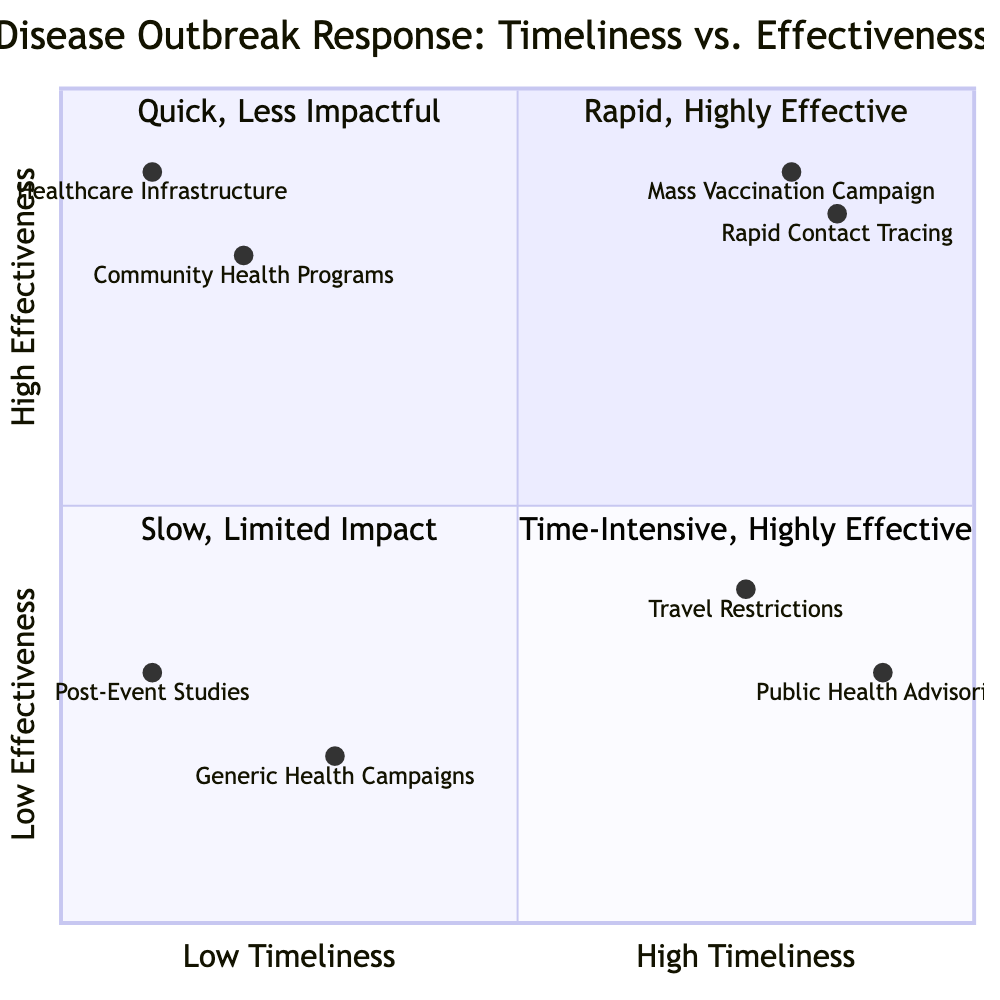What intervention is positioned in the high timeliness and high effectiveness quadrant? The diagram indicates that the interventions placed in the high timeliness and high effectiveness quadrant are the Mass Vaccination Campaign and Rapid Contact Tracing and Isolation. These interventions are effective in quickly addressing disease outbreaks.
Answer: Mass Vaccination Campaign, Rapid Contact Tracing and Isolation How many interventions are in the low timeliness and high effectiveness quadrant? By examining the diagram, it shows there are two interventions in the low timeliness and high effectiveness quadrant: Community Health Outreach Programs and Infrastructure Improvements in Healthcare Facilities. Thus, the count is two.
Answer: 2 Which intervention has the highest effectiveness among those classified as low timeliness? Looking at the diagram, the intervention classified as low timeliness but high effectiveness is Infrastructure Improvements in Healthcare Facilities, which is ranked higher compared to the others in that category.
Answer: Infrastructure Improvements in Healthcare Facilities What is the effectiveness score of Public Health Advisories? The diagram states that Public Health Advisories have an effectiveness score of 0.3. This score reflects its limited impact despite being timely advice for the public.
Answer: 0.3 Which intervention has the lowest timeliness score? A review of the diagram reveals that Post-Event Epidemiological Studies have the lowest timeliness score at 0.1, indicating a significant delay in response capability.
Answer: Post-Event Epidemiological Studies In which quadrant does the Travel Bans and Restrictions intervention fall? The intervention Travel Bans and Restrictions is classified in the quadrant for high timeliness and low effectiveness, as it allows for immediate action but does not effectively control the outbreak in the long term.
Answer: High Timeliness, Low Effectiveness What is the most effective intervention overall? The diagram shows that the intervention with the highest effectiveness score is the Mass Vaccination Campaign, scoring 0.9, which indicates its strong impact during outbreaks.
Answer: Mass Vaccination Campaign How many interventions are there in total on the chart? Counting the interventions across all quadrants in the diagram, there are eight distinct interventions listed.
Answer: 8 Which quadrant contains the Generic Public Health Campaigns? The diagram places Generic Public Health Campaigns in the low timeliness and low effectiveness quadrant, illustrating its slow and limited response to outbreaks.
Answer: Low Timeliness, Low Effectiveness 